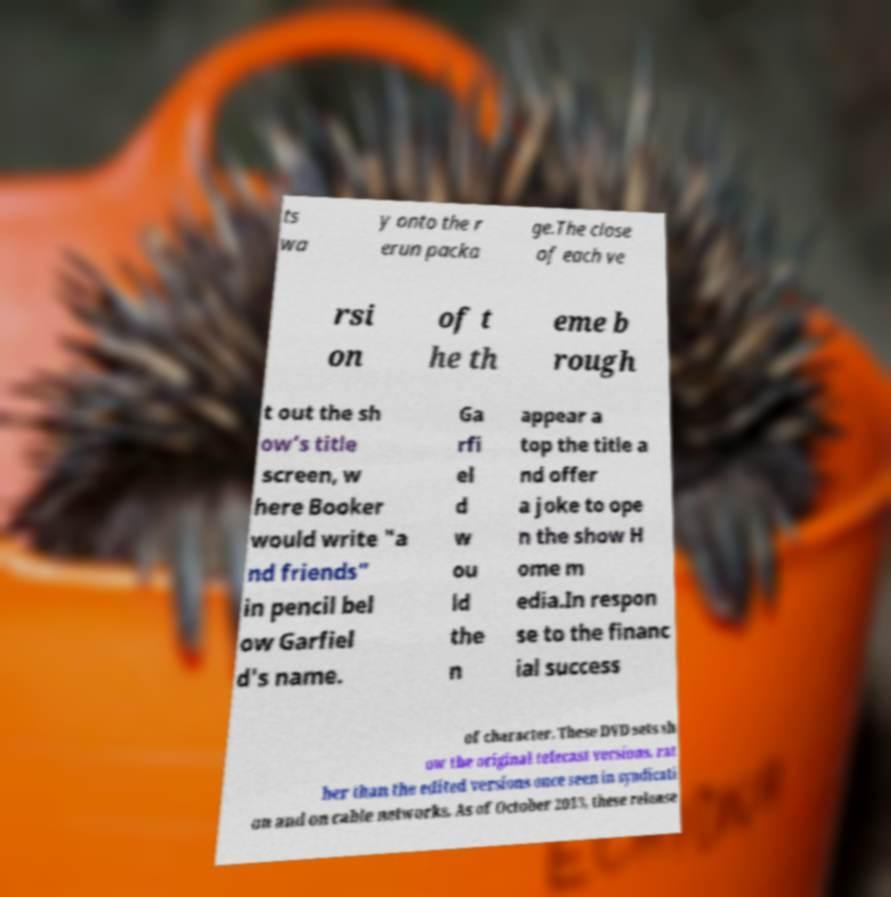I need the written content from this picture converted into text. Can you do that? ts wa y onto the r erun packa ge.The close of each ve rsi on of t he th eme b rough t out the sh ow's title screen, w here Booker would write "a nd friends" in pencil bel ow Garfiel d's name. Ga rfi el d w ou ld the n appear a top the title a nd offer a joke to ope n the show H ome m edia.In respon se to the financ ial success of character. These DVD sets sh ow the original telecast versions, rat her than the edited versions once seen in syndicati on and on cable networks. As of October 2013, these release 